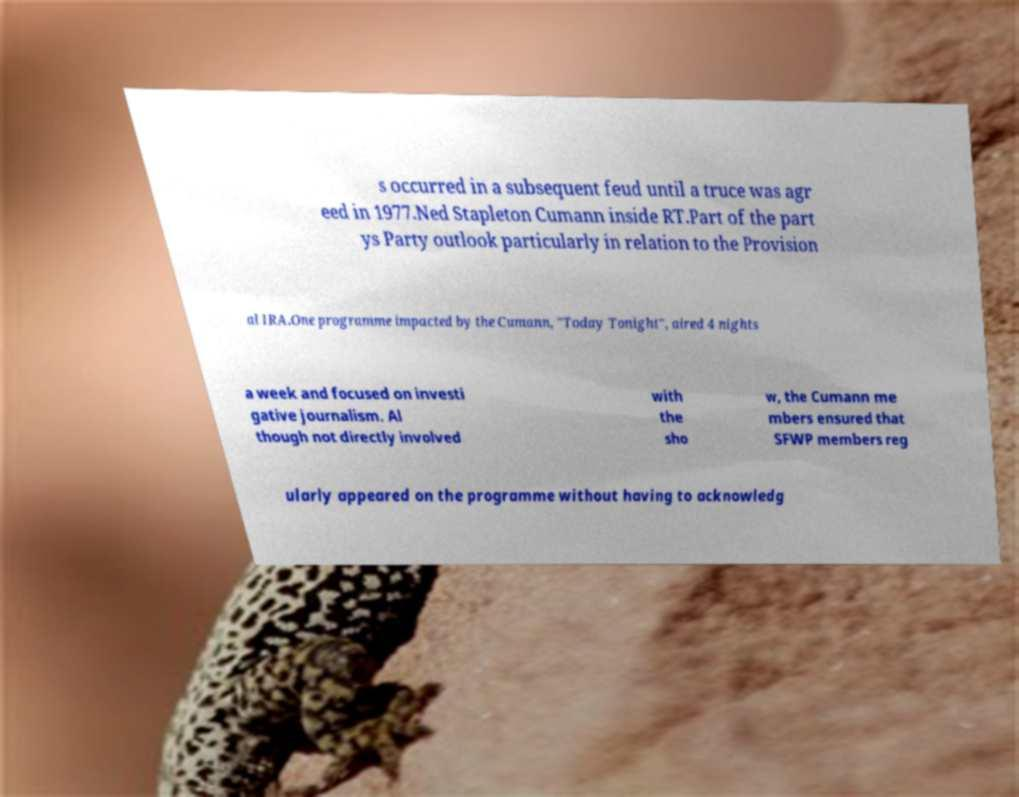Can you accurately transcribe the text from the provided image for me? s occurred in a subsequent feud until a truce was agr eed in 1977.Ned Stapleton Cumann inside RT.Part of the part ys Party outlook particularly in relation to the Provision al IRA.One programme impacted by the Cumann, "Today Tonight", aired 4 nights a week and focused on investi gative journalism. Al though not directly involved with the sho w, the Cumann me mbers ensured that SFWP members reg ularly appeared on the programme without having to acknowledg 